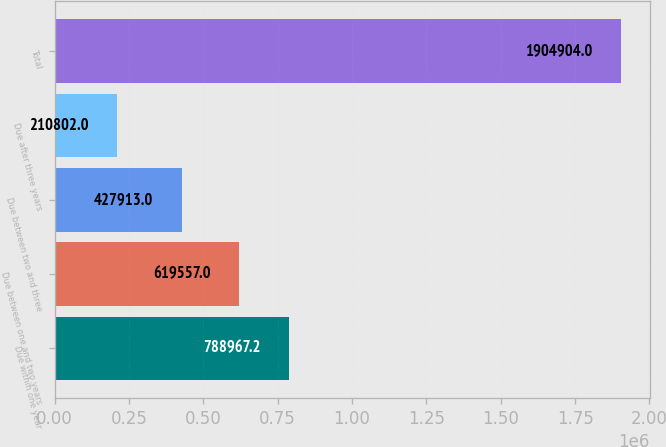Convert chart to OTSL. <chart><loc_0><loc_0><loc_500><loc_500><bar_chart><fcel>Due within one year<fcel>Due between one and two years<fcel>Due between two and three<fcel>Due after three years<fcel>Total<nl><fcel>788967<fcel>619557<fcel>427913<fcel>210802<fcel>1.9049e+06<nl></chart> 